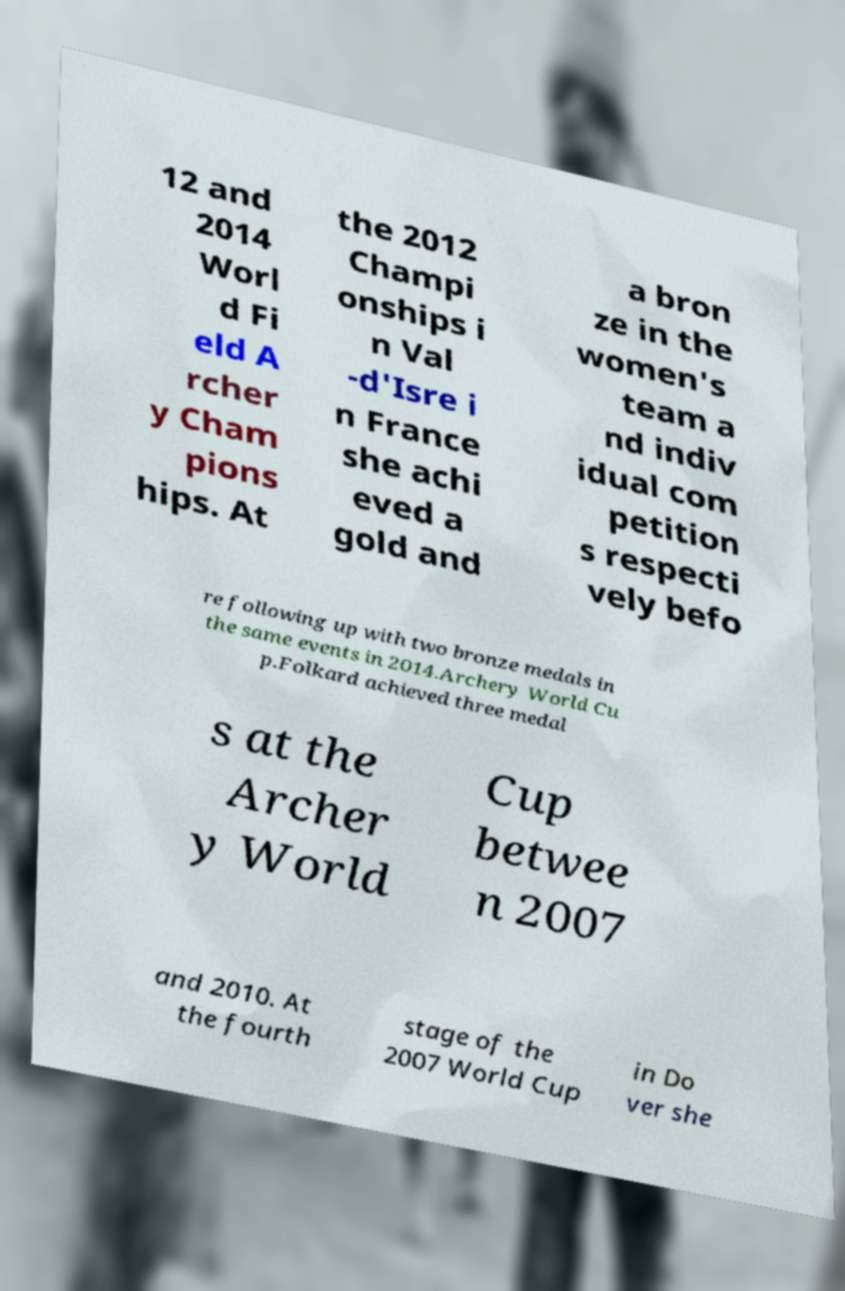What messages or text are displayed in this image? I need them in a readable, typed format. 12 and 2014 Worl d Fi eld A rcher y Cham pions hips. At the 2012 Champi onships i n Val -d'Isre i n France she achi eved a gold and a bron ze in the women's team a nd indiv idual com petition s respecti vely befo re following up with two bronze medals in the same events in 2014.Archery World Cu p.Folkard achieved three medal s at the Archer y World Cup betwee n 2007 and 2010. At the fourth stage of the 2007 World Cup in Do ver she 